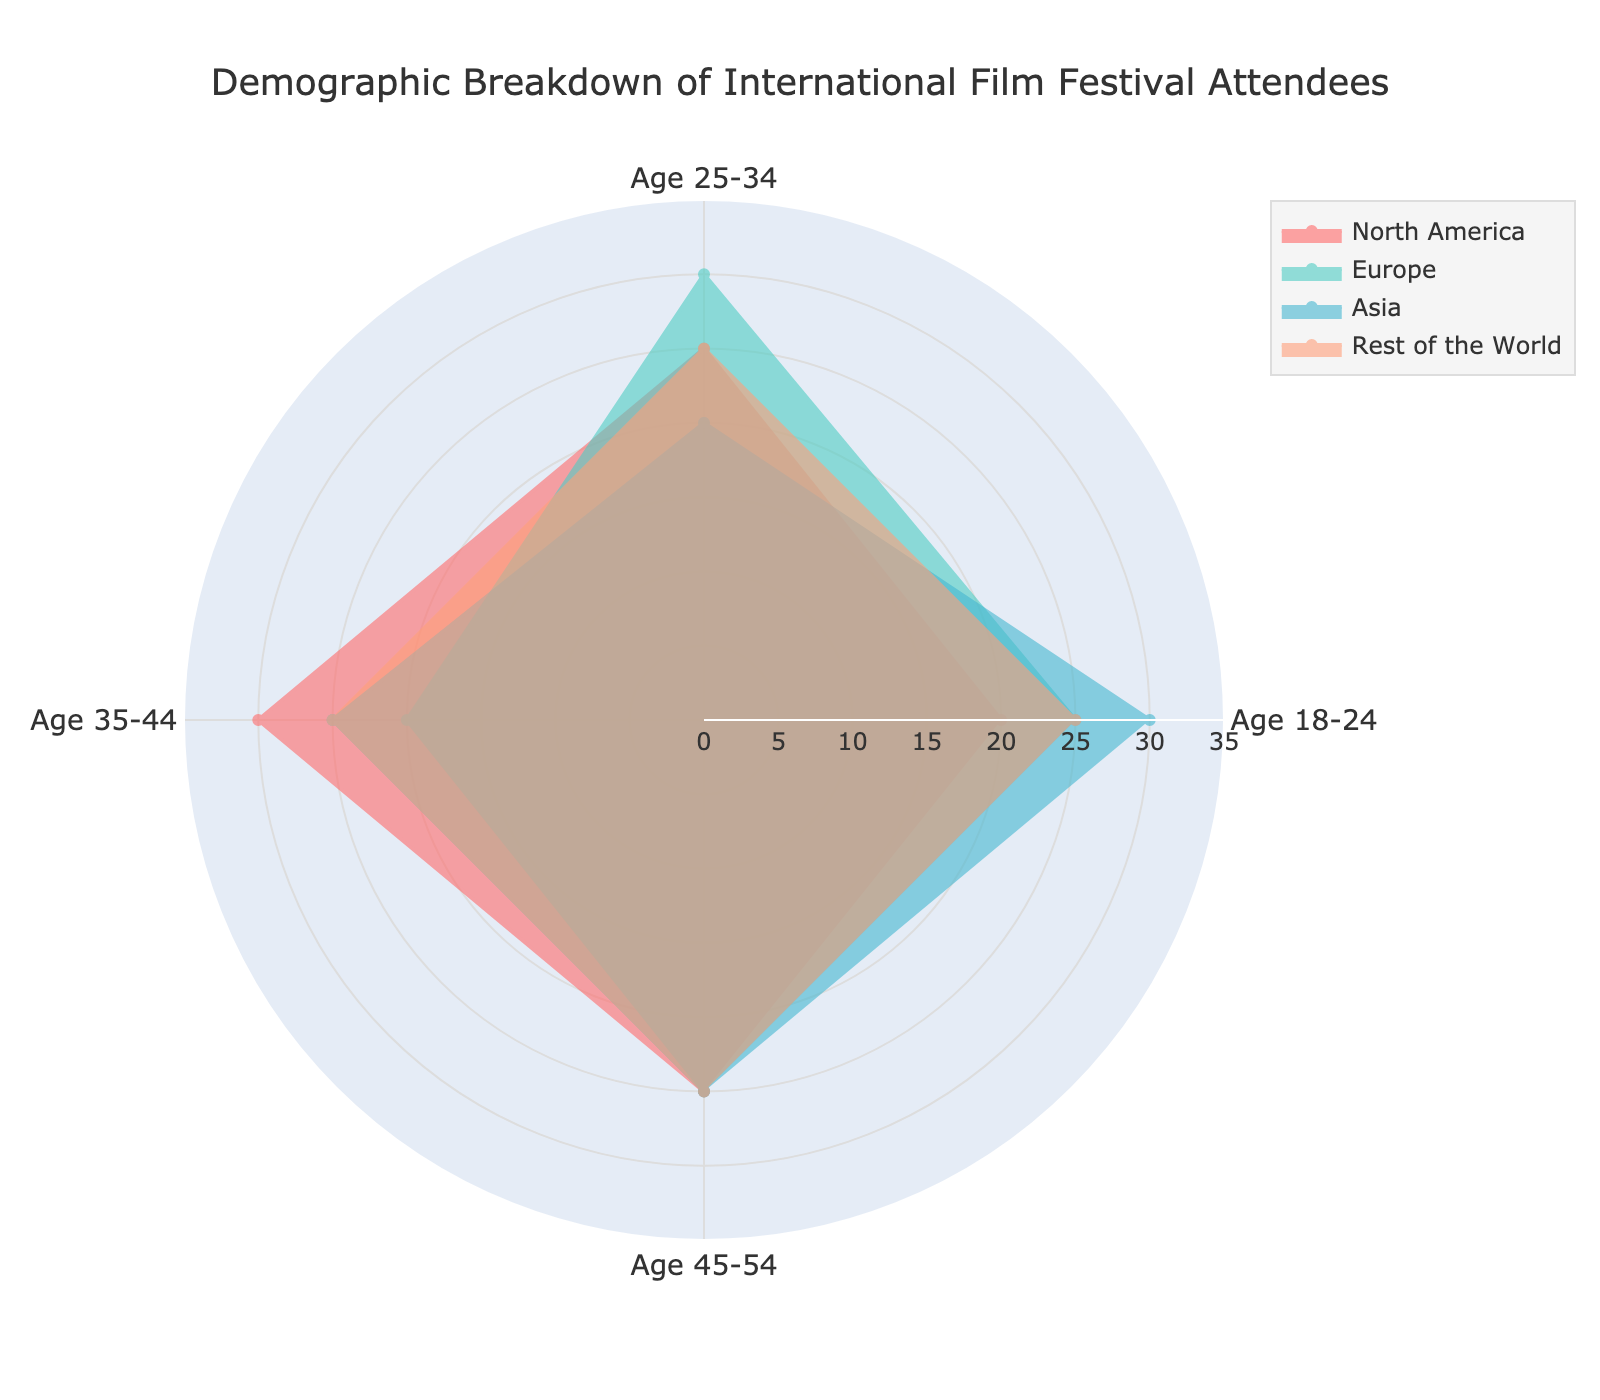Which region has the highest percentage of attendees aged 18-24? To determine the region with the highest percentage of attendees aged 18-24, we compare the values for this age group across the regions. North America has 20%, Europe 25%, Asia 30%, and Rest of the World 25%. Asia has the highest value at 30%.
Answer: Asia Which age group in North America has the lowest percentage of attendees? We need to compare the percentages for each age group within North America. The values are 18-24 (20%), 25-34 (25%), 35-44 (30%), and 45-54 (25%). The lowest percentage is 20% in the 18-24 age group.
Answer: 18-24 What is the average percentage of attendees aged 25-34 across all regions? We sum the percentages of attendees aged 25-34 across North America (25%), Europe (30%), Asia (20%), and Rest of the World (25%) and then divide by the number of regions. (25 + 30 + 20 + 25) / 4 = 25%.
Answer: 25% Which region has the most balanced demographic distribution across all age groups? A balanced distribution would mean the percentages across different age groups are close to each other. Checking the values for each region, we find that the Rest of the World has 25% in each age group, which is the most balanced.
Answer: Rest of the World What is the difference in the percentage of attendees aged 35-44 between North America and Europe? We find the percentages for the 35-44 age group in both regions. North America has 30% and Europe has 20%. The difference is 30% - 20% = 10%.
Answer: 10% Which age group in Asia has the highest number of attendees, and what is the percentage? Looking at the percentages for Asia, the values are 18-24 (30%), 25-34 (20%), 35-44 (25%), and 45-54 (25%). The highest percentage is 30% in the 18-24 age group.
Answer: 18-24, 30% Is the percentage of attendees aged 45-54 equal across all regions? We check the values for the 45-54 age group in each region: North America (25%), Europe (25%), Asia (25%), and Rest of the World (25%). All these values are equal.
Answer: Yes Among the 35-44 age group, which region has the highest percentage and what is it? We compare the percentages for the 35-44 age group across all regions: North America (30%), Europe (20%), Asia (25%), and Rest of the World (25%). North America has the highest percentage at 30%.
Answer: North America, 30% 